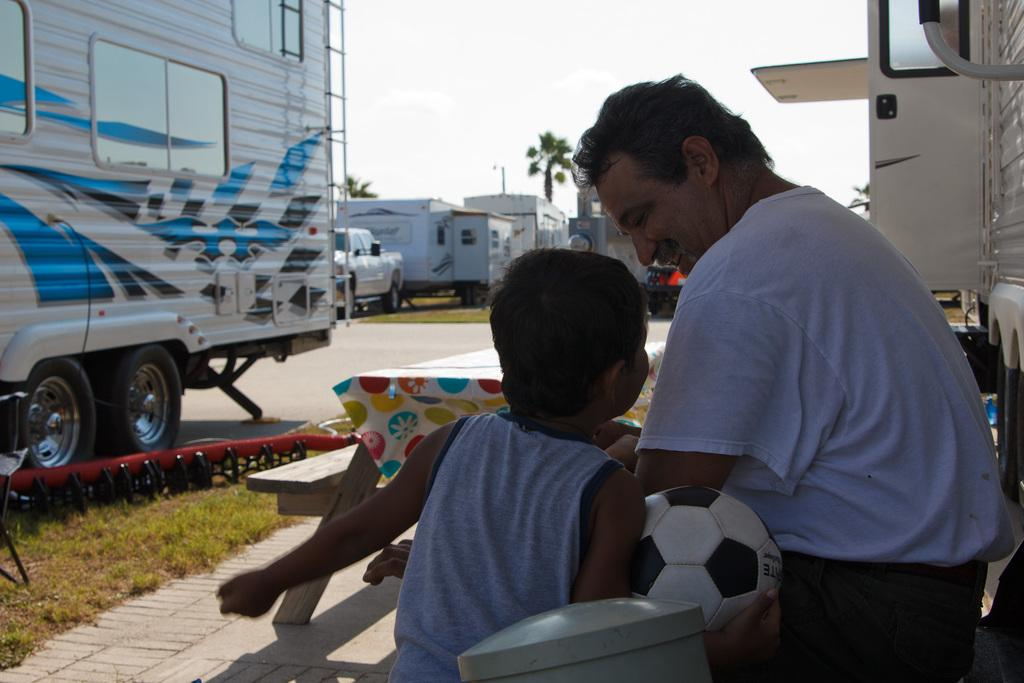How many people are sitting in the image? There are two people sitting on chairs in the image. Can you describe the small boy in the image? The small boy is in the image and he is holding a ball. What else can be seen in the image besides the people and the small boy? There is a vehicle in the image. What type of smell can be detected coming from the children in the image? There is no mention of a smell or children in the image, so it cannot be determined from the image. 